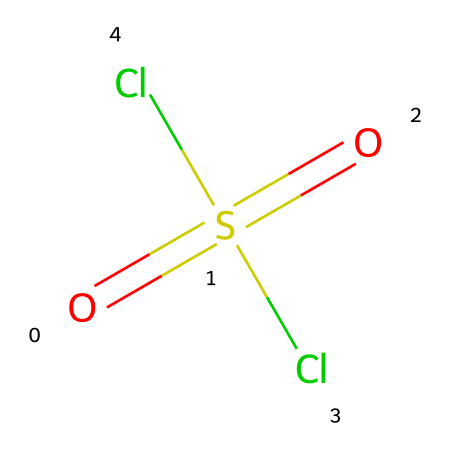What is the total number of chlorine atoms in sulfuryl chloride? The chemical structure shows two chlorine atoms represented by the "Cl" symbols.
Answer: two What is the oxidation state of sulfur in sulfuryl chloride? In sulfuryl chloride, sulfur is bonded to two oxygen atoms (which each have a formal oxidation state of -2) and two chlorine atoms (which do not contribute to the oxidation state here). The oxidation state of sulfur can be calculated as +6, considering that there are four bond regions around the sulfur atom.
Answer: +6 How many double bonds are present in sulfuryl chloride? The structure shows one double bond between the sulfur atom and each oxygen atom, totaling two double bonds.
Answer: two What is the primary functional group in sulfuryl chloride? The compounds' distinguishing feature is the sulfonyl group (-SO2-), which is indicated by the two double bonds to oxygen from the sulfur atom, making it a sulfonyl chloride.
Answer: sulfonyl What effect do the chlorine atoms have on the reactivity of sulfuryl chloride? The presence of two electronegative chlorine atoms can enhance the electrophilic character of the sulfur atom, making it more reactive towards nucleophiles. This reactivity is due to chlorine atoms initiating positive polarization on the sulfur.
Answer: enhance reactivity Which atoms are directly bonded to sulfur in sulfuryl chloride? Analyzing the structure, sulfur is directly connected to two chlorine atoms and two oxygen atoms through strong covalent bonds, confirming that these four atoms are directly bonded to sulfur.
Answer: two chlorines and two oxygens 